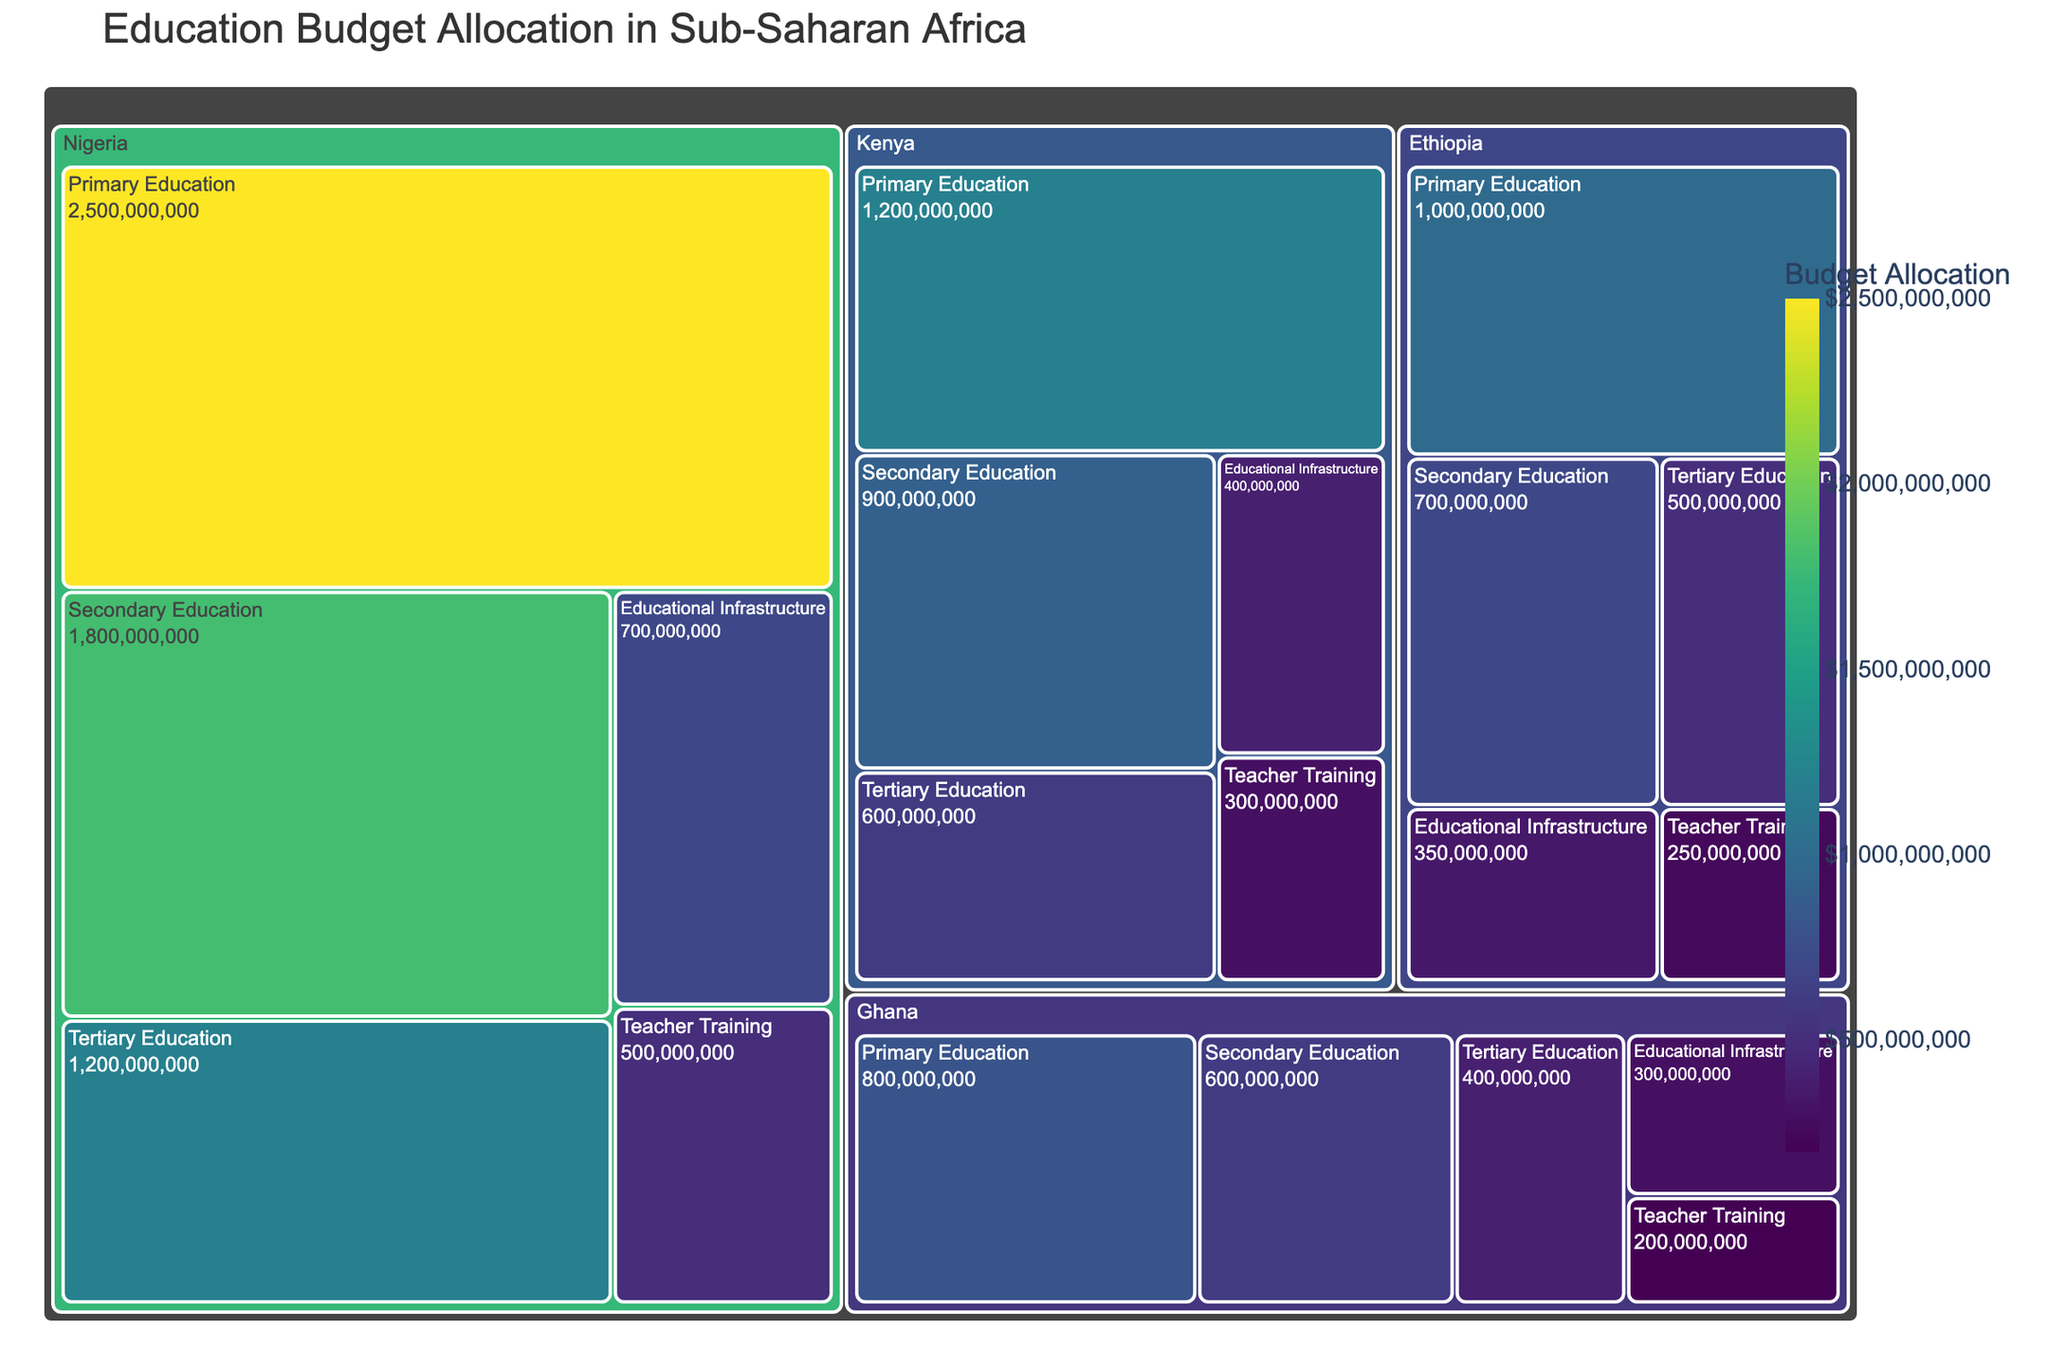Which country allocates the most budget to primary education? By looking at the size of the sections for primary education across all countries in the treemap, Nigeria has the largest section for primary education, indicating the highest budget allocation.
Answer: Nigeria What is the total budget allocation for secondary education across all the displayed countries? Summing up the budget allocations for secondary education in each country: Nigeria ($1.8 billion), Kenya ($900 million), Ghana ($600 million), and Ethiopia ($700 million) gives a total of $4 billion.
Answer: $4 billion Which sector has the smallest budget allocation within Ghana? By comparing the sizes of the sections corresponding to each sector within Ghana in the treemap, the Teacher Training sector is the smallest.
Answer: Teacher Training How does the budget allocation for educational infrastructure in Ethiopia compare to that in Kenya? The budget allocation for educational infrastructure in Ethiopia is $350 million, which is smaller compared to Kenya's $400 million.
Answer: Ethiopia's is smaller What is the total budget allocation for Nigeria? Adding up the budget allocations across all sectors in Nigeria: $2.5 billion (Primary), $1.8 billion (Secondary), $1.2 billion (Tertiary), $500 million (Teacher Training), and $700 million (Educational Infrastructure) results in a total of $6.7 billion.
Answer: $6.7 billion Which country's tertiary education budget allocation is the lowest? By comparing the sizes of the sections for tertiary education in all countries, Ghana's section is the smallest, indicating the lowest budget allocation.
Answer: Ghana How much more is allocated to primary education than to teacher training in Kenya? The budget allocation for primary education in Kenya is $1.2 billion, and for teacher training, it is $300 million. The difference is $1.2 billion - $300 million = $900 million.
Answer: $900 million What proportion of Ethiopia's total education budget is allocated to secondary education? Ethiopia's total education budget is the sum of all sectors, which is $1 billion (Primary) + $700 million (Secondary) + $500 million (Tertiary) + $250 million (Teacher Training) + $350 million (Educational Infrastructure) = $2.8 billion. The proportion allocated to secondary education is $700 million / $2.8 billion = 0.25 or 25%.
Answer: 25% How does the education budget allocation pattern in Nigeria differ from that in Ghana? Nigeria allocates more significantly across all sectors compared to Ghana, particularly in primary education where Nigeria allocates $2.5 billion whereas Ghana allocates $800 million. This pattern holds across secondary, tertiary, teacher training, and infrastructure as well, with Nigeria consistently having larger allocations.
Answer: Nigeria allocates more in all sectors Which country has the highest total budget allocation for educational infrastructure? Comparing the sizes of the sections for educational infrastructure across all countries, Nigeria has the largest section, indicating the highest budget allocation in this sector.
Answer: Nigeria 